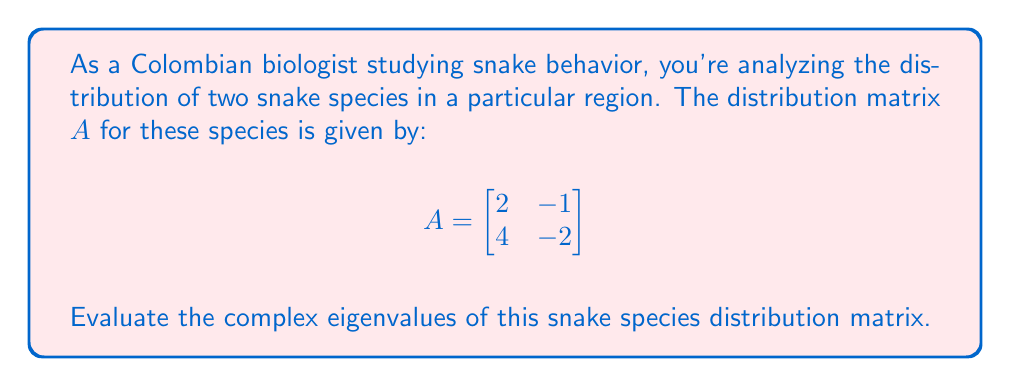What is the answer to this math problem? To find the complex eigenvalues of the matrix A, we need to follow these steps:

1) First, we need to find the characteristic equation of the matrix. The characteristic equation is given by:

   $\det(A - \lambda I) = 0$

   where $\lambda$ represents the eigenvalues, and $I$ is the 2x2 identity matrix.

2) Let's expand this:

   $$\det\begin{bmatrix}
   2-\lambda & -1 \\
   4 & -2-\lambda
   \end{bmatrix} = 0$$

3) Calculate the determinant:

   $(2-\lambda)(-2-\lambda) - (-1)(4) = 0$

4) Expand the equation:

   $\lambda^2 + 0\lambda + 0 = 0$

5) This is our characteristic equation. To solve for $\lambda$, we can factor this equation:

   $\lambda^2 = 0$
   $\lambda(\lambda) = 0$

6) Solve for $\lambda$:

   $\lambda = 0$ (with algebraic multiplicity 2)

Therefore, the matrix has a repeated eigenvalue of 0.

In the context of snake species distribution, this result suggests that the distribution patterns of these two snake species are linearly dependent. This could indicate that the two species have very similar habitat preferences or that one species' distribution is directly influenced by the other's.
Answer: The complex eigenvalues of the snake species distribution matrix are $\lambda_1 = \lambda_2 = 0$. 